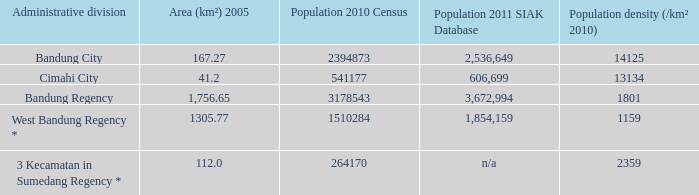What is the population density of bandung regency? 1801.0. 